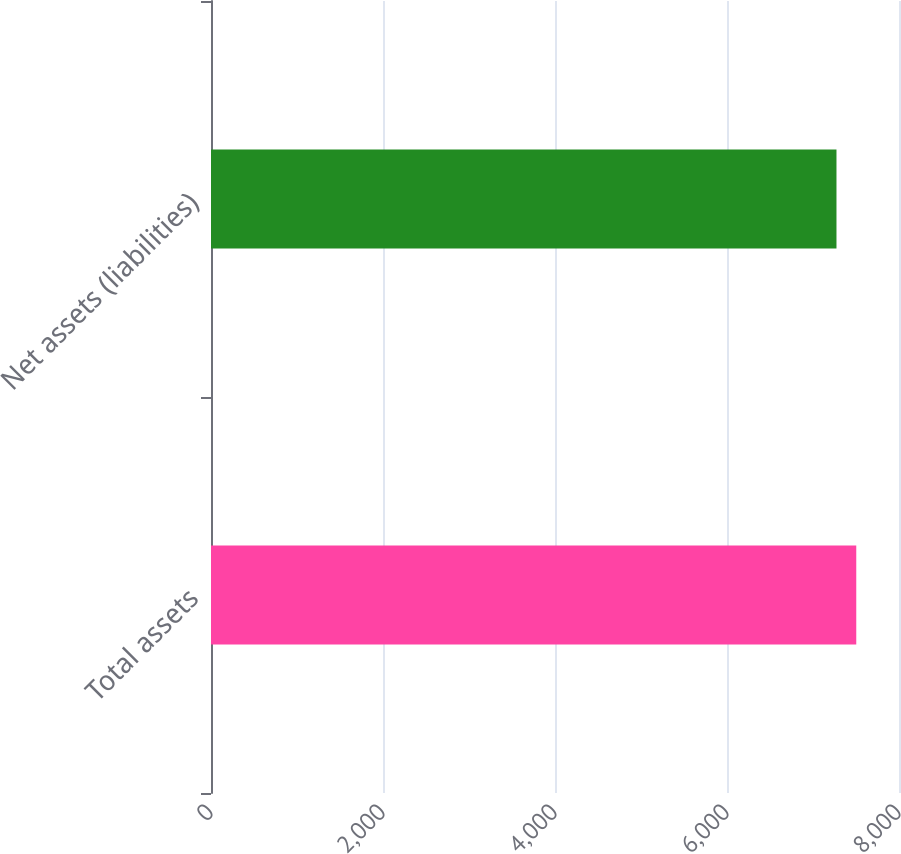Convert chart. <chart><loc_0><loc_0><loc_500><loc_500><bar_chart><fcel>Total assets<fcel>Net assets (liabilities)<nl><fcel>7503<fcel>7273<nl></chart> 